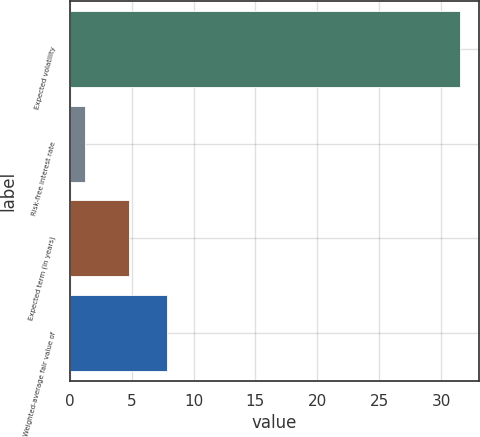Convert chart. <chart><loc_0><loc_0><loc_500><loc_500><bar_chart><fcel>Expected volatility<fcel>Risk-free interest rate<fcel>Expected term (in years)<fcel>Weighted-average fair value of<nl><fcel>31.5<fcel>1.21<fcel>4.8<fcel>7.83<nl></chart> 